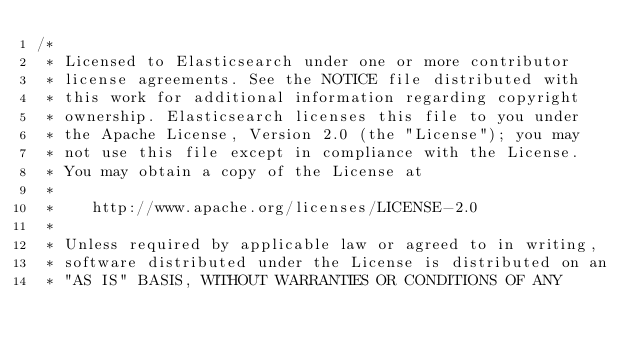<code> <loc_0><loc_0><loc_500><loc_500><_Java_>/*
 * Licensed to Elasticsearch under one or more contributor
 * license agreements. See the NOTICE file distributed with
 * this work for additional information regarding copyright
 * ownership. Elasticsearch licenses this file to you under
 * the Apache License, Version 2.0 (the "License"); you may
 * not use this file except in compliance with the License.
 * You may obtain a copy of the License at
 *
 *    http://www.apache.org/licenses/LICENSE-2.0
 *
 * Unless required by applicable law or agreed to in writing,
 * software distributed under the License is distributed on an
 * "AS IS" BASIS, WITHOUT WARRANTIES OR CONDITIONS OF ANY</code> 